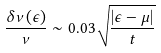<formula> <loc_0><loc_0><loc_500><loc_500>\frac { \delta \nu ( \epsilon ) } { \nu } \sim 0 . 0 3 \sqrt { \frac { | \epsilon - \mu | } { t } }</formula> 